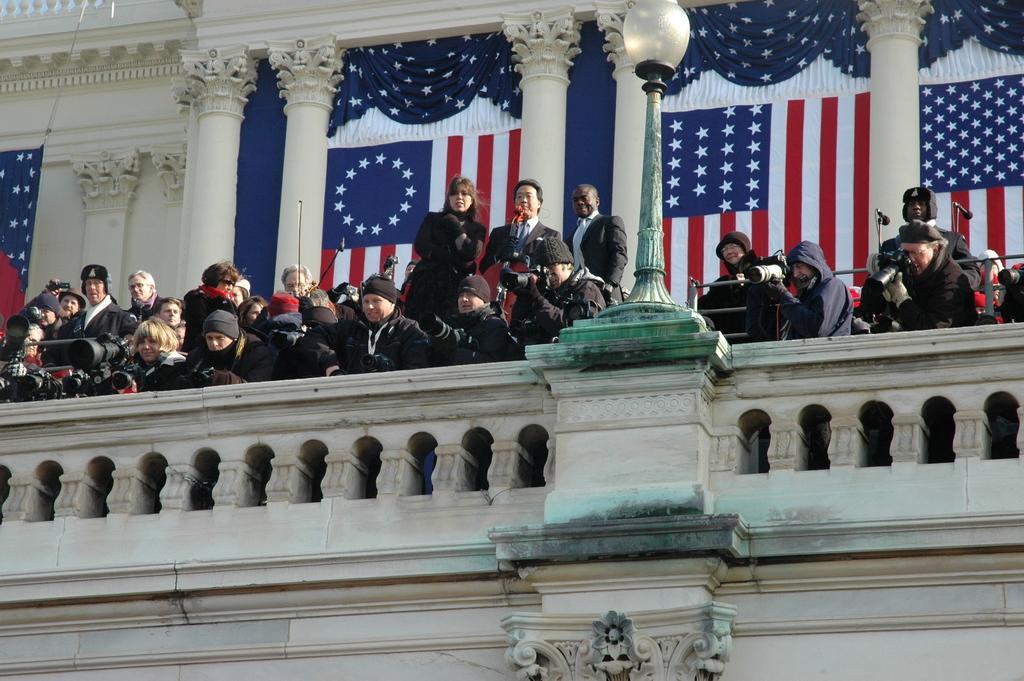Describe this image in one or two sentences. Here in this picture we can see number of people standing over a place and some people are capturing the moment with cameras in their hand and the person in the middle is speaking something with microphone in his hand and we can see a lamp post present and behind them we can see flags present on the wall and we can see pillars of the building over there. 